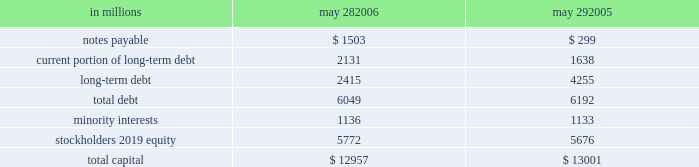During fiscal 2006 , we repurchased 19 million shares of common stock for an aggregate purchase price of $ 892 million , of which $ 7 million settled after the end of our fiscal year .
In fiscal 2005 , we repurchased 17 million shares of common stock for an aggregate purchase price of $ 771 million .
A total of 146 million shares were held in treasury at may 28 , 2006 .
We also used cash from operations to repay $ 189 million in outstanding debt in fiscal 2006 .
In fiscal 2005 , we repaid nearly $ 2.2 billion of debt , including the purchase of $ 760 million principal amount of our 6 percent notes due in 2012 .
Fiscal 2005 debt repurchase costs were $ 137 million , consisting of $ 73 million of noncash interest rate swap losses reclassified from accumulated other comprehen- sive income , $ 59 million of purchase premium and $ 5 million of noncash unamortized cost of issuance expense .
Capital structure in millions may 28 , may 29 .
We have $ 2.1 billion of long-term debt maturing in the next 12 months and classified as current , including $ 131 million that may mature in fiscal 2007 based on the put rights of those note holders .
We believe that cash flows from operations , together with available short- and long- term debt financing , will be adequate to meet our liquidity and capital needs for at least the next 12 months .
On october 28 , 2005 , we repurchased a significant portion of our zero coupon convertible debentures pursuant to put rights of the holders for an aggregate purchase price of $ 1.33 billion , including $ 77 million of accreted original issue discount .
These debentures had an aggregate prin- cipal amount at maturity of $ 1.86 billion .
We incurred no gain or loss from this repurchase .
As of may 28 , 2006 , there were $ 371 million in aggregate principal amount at matu- rity of the debentures outstanding , or $ 268 million of accreted value .
We used proceeds from the issuance of commercial paper to fund the purchase price of the deben- tures .
We also have reclassified the remaining zero coupon convertible debentures to long-term debt based on the october 2008 put rights of the holders .
On march 23 , 2005 , we commenced a cash tender offer for our outstanding 6 percent notes due in 2012 .
The tender offer resulted in the purchase of $ 500 million principal amount of the notes .
Subsequent to the expiration of the tender offer , we purchased an additional $ 260 million prin- cipal amount of the notes in the open market .
The aggregate purchases resulted in the debt repurchase costs as discussed above .
Our minority interests consist of interests in certain of our subsidiaries that are held by third parties .
General mills cereals , llc ( gmc ) , our subsidiary , holds the manufac- turing assets and intellectual property associated with the production and retail sale of big g ready-to-eat cereals , progresso soups and old el paso products .
In may 2002 , one of our wholly owned subsidiaries sold 150000 class a preferred membership interests in gmc to an unrelated third-party investor in exchange for $ 150 million , and in october 2004 , another of our wholly owned subsidiaries sold 835000 series b-1 preferred membership interests in gmc in exchange for $ 835 million .
All interests in gmc , other than the 150000 class a interests and 835000 series b-1 interests , but including all managing member inter- ests , are held by our wholly owned subsidiaries .
In fiscal 2003 , general mills capital , inc .
( gm capital ) , a subsidiary formed for the purpose of purchasing and collecting our receivables , sold $ 150 million of its series a preferred stock to an unrelated third-party investor .
The class a interests of gmc receive quarterly preferred distributions at a floating rate equal to ( i ) the sum of three- month libor plus 90 basis points , divided by ( ii ) 0.965 .
This rate will be adjusted by agreement between the third- party investor holding the class a interests and gmc every five years , beginning in june 2007 .
Under certain circum- stances , gmc also may be required to be dissolved and liquidated , including , without limitation , the bankruptcy of gmc or its subsidiaries , failure to deliver the preferred distributions , failure to comply with portfolio requirements , breaches of certain covenants , lowering of our senior debt rating below either baa3 by moody 2019s or bbb by standard & poor 2019s , and a failed attempt to remarket the class a inter- ests as a result of a breach of gmc 2019s obligations to assist in such remarketing .
In the event of a liquidation of gmc , each member of gmc would receive the amount of its then current capital account balance .
The managing member may avoid liquidation in most circumstances by exercising an option to purchase the class a interests .
The series b-1 interests of gmc are entitled to receive quarterly preferred distributions at a fixed rate of 4.5 percent per year , which is scheduled to be reset to a new fixed rate through a remarketing in october 2007 .
Beginning in october 2007 , the managing member of gmc may elect to repurchase the series b-1 interests for an amount equal to the holder 2019s then current capital account balance plus any applicable make-whole amount .
Gmc is not required to purchase the series b-1 interests nor may these investors put these interests to us .
The series b-1 interests will be exchanged for shares of our perpetual preferred stock upon the occurrence of any of the following events : our senior unsecured debt rating falling below either ba3 as rated by moody 2019s or bb- as rated by standard & poor 2019s or fitch , inc. .
What is the average price per share for the repurchased shares during 2005? 
Computations: (771 / 17)
Answer: 45.35294. 